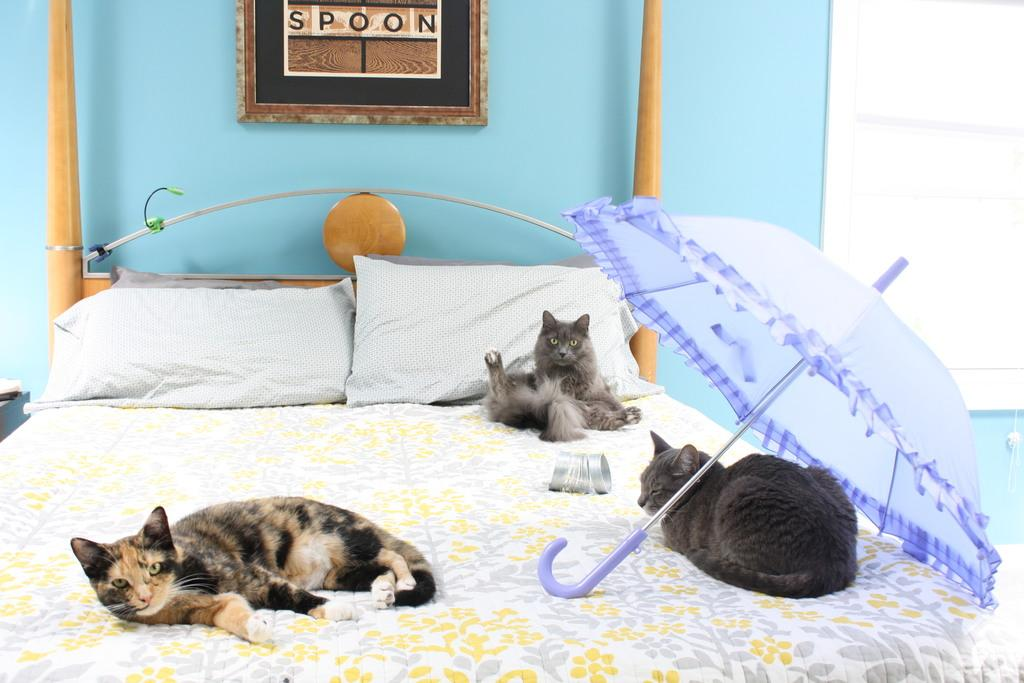How many cats are lying on the bed in the image? There are 3 cats lying on the bed in the image. What other objects can be seen in the image besides the cats? There is an umbrella and 2 pillows in the image. What is visible in the background of the image? There is a wall in the background of the image. Can you describe any additional details about the wall? There is a photo frame attached to the wall in the background. What time does the clock in the image show? There is no clock present in the image, so it is not possible to determine the time. 